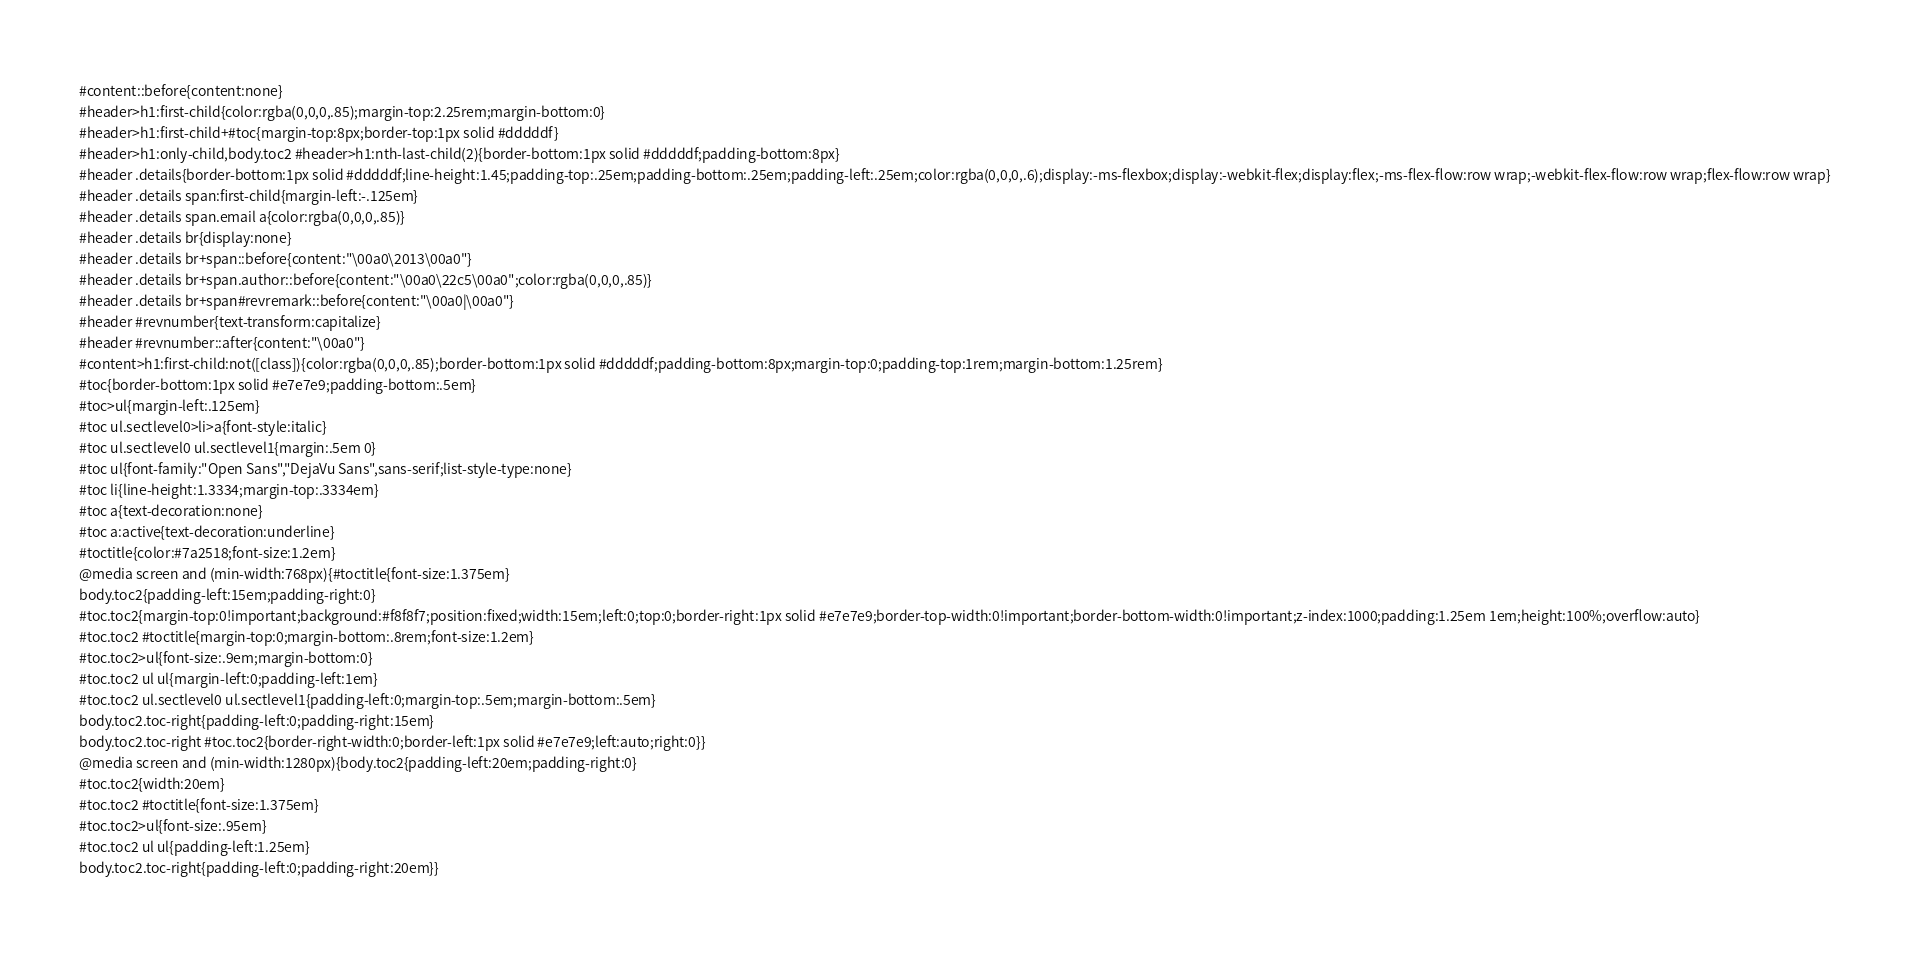<code> <loc_0><loc_0><loc_500><loc_500><_HTML_>#content::before{content:none}
#header>h1:first-child{color:rgba(0,0,0,.85);margin-top:2.25rem;margin-bottom:0}
#header>h1:first-child+#toc{margin-top:8px;border-top:1px solid #dddddf}
#header>h1:only-child,body.toc2 #header>h1:nth-last-child(2){border-bottom:1px solid #dddddf;padding-bottom:8px}
#header .details{border-bottom:1px solid #dddddf;line-height:1.45;padding-top:.25em;padding-bottom:.25em;padding-left:.25em;color:rgba(0,0,0,.6);display:-ms-flexbox;display:-webkit-flex;display:flex;-ms-flex-flow:row wrap;-webkit-flex-flow:row wrap;flex-flow:row wrap}
#header .details span:first-child{margin-left:-.125em}
#header .details span.email a{color:rgba(0,0,0,.85)}
#header .details br{display:none}
#header .details br+span::before{content:"\00a0\2013\00a0"}
#header .details br+span.author::before{content:"\00a0\22c5\00a0";color:rgba(0,0,0,.85)}
#header .details br+span#revremark::before{content:"\00a0|\00a0"}
#header #revnumber{text-transform:capitalize}
#header #revnumber::after{content:"\00a0"}
#content>h1:first-child:not([class]){color:rgba(0,0,0,.85);border-bottom:1px solid #dddddf;padding-bottom:8px;margin-top:0;padding-top:1rem;margin-bottom:1.25rem}
#toc{border-bottom:1px solid #e7e7e9;padding-bottom:.5em}
#toc>ul{margin-left:.125em}
#toc ul.sectlevel0>li>a{font-style:italic}
#toc ul.sectlevel0 ul.sectlevel1{margin:.5em 0}
#toc ul{font-family:"Open Sans","DejaVu Sans",sans-serif;list-style-type:none}
#toc li{line-height:1.3334;margin-top:.3334em}
#toc a{text-decoration:none}
#toc a:active{text-decoration:underline}
#toctitle{color:#7a2518;font-size:1.2em}
@media screen and (min-width:768px){#toctitle{font-size:1.375em}
body.toc2{padding-left:15em;padding-right:0}
#toc.toc2{margin-top:0!important;background:#f8f8f7;position:fixed;width:15em;left:0;top:0;border-right:1px solid #e7e7e9;border-top-width:0!important;border-bottom-width:0!important;z-index:1000;padding:1.25em 1em;height:100%;overflow:auto}
#toc.toc2 #toctitle{margin-top:0;margin-bottom:.8rem;font-size:1.2em}
#toc.toc2>ul{font-size:.9em;margin-bottom:0}
#toc.toc2 ul ul{margin-left:0;padding-left:1em}
#toc.toc2 ul.sectlevel0 ul.sectlevel1{padding-left:0;margin-top:.5em;margin-bottom:.5em}
body.toc2.toc-right{padding-left:0;padding-right:15em}
body.toc2.toc-right #toc.toc2{border-right-width:0;border-left:1px solid #e7e7e9;left:auto;right:0}}
@media screen and (min-width:1280px){body.toc2{padding-left:20em;padding-right:0}
#toc.toc2{width:20em}
#toc.toc2 #toctitle{font-size:1.375em}
#toc.toc2>ul{font-size:.95em}
#toc.toc2 ul ul{padding-left:1.25em}
body.toc2.toc-right{padding-left:0;padding-right:20em}}</code> 